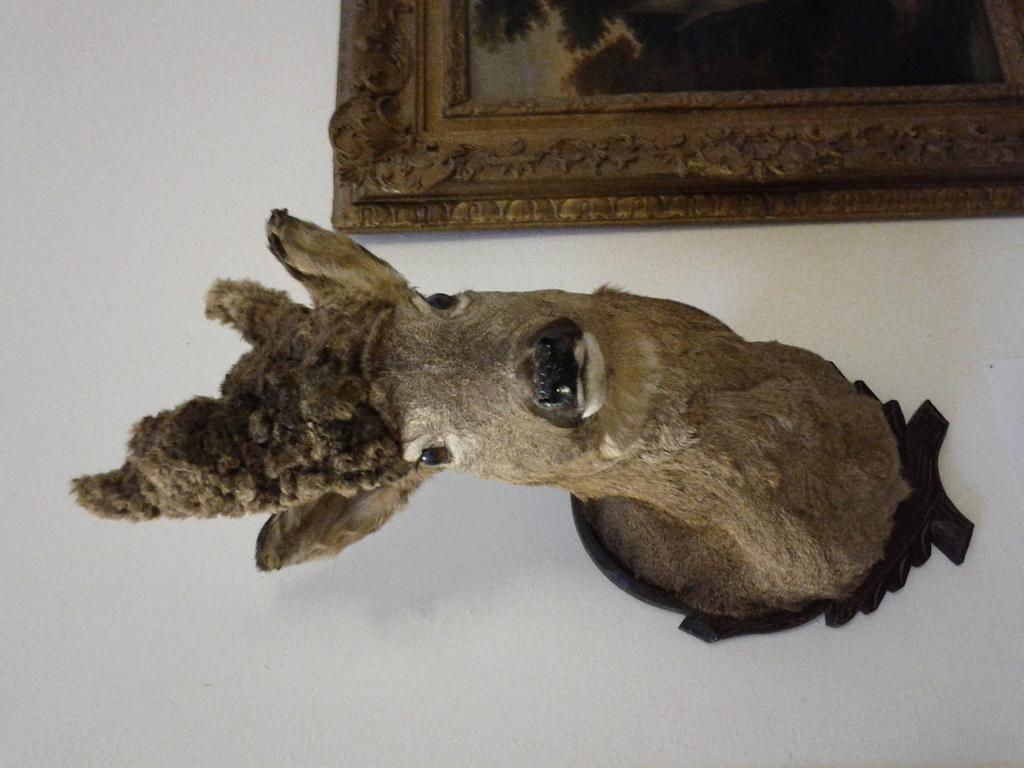What is on the wall in the image? There is a statue on the wall in the image. What is located beside the statue? There is a painting beside the statue. What is depicted in the painting? The painting depicts the sky and trees. Can you see the uncle smiling in the painting? There is no uncle or any people depicted in the painting; it only shows the sky and trees. 